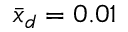<formula> <loc_0><loc_0><loc_500><loc_500>\bar { x } _ { d } = 0 . 0 1</formula> 